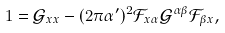Convert formula to latex. <formula><loc_0><loc_0><loc_500><loc_500>1 = \mathcal { G } _ { x x } - ( 2 \pi \alpha ^ { \prime } ) ^ { 2 } \mathcal { F } _ { x \alpha } \mathcal { G } ^ { \alpha \beta } \mathcal { F } _ { \beta x } ,</formula> 